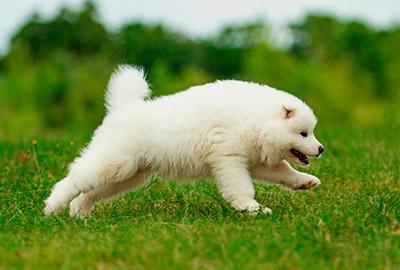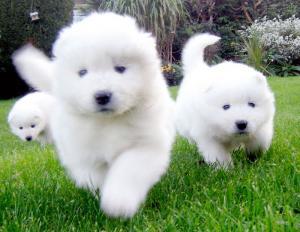The first image is the image on the left, the second image is the image on the right. For the images shown, is this caption "An image shows at least one dog running toward the camera." true? Answer yes or no. Yes. 